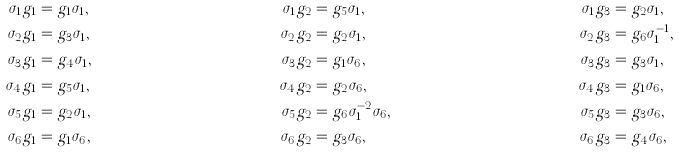<formula> <loc_0><loc_0><loc_500><loc_500>\sigma _ { 1 } g _ { 1 } & = g _ { 1 } \sigma _ { 1 } , & \sigma _ { 1 } g _ { 2 } & = g _ { 5 } \sigma _ { 1 } , & \sigma _ { 1 } g _ { 3 } & = g _ { 2 } \sigma _ { 1 } , \\ \sigma _ { 2 } g _ { 1 } & = g _ { 3 } \sigma _ { 1 } , & \sigma _ { 2 } g _ { 2 } & = g _ { 2 } \sigma _ { 1 } , & \sigma _ { 2 } g _ { 3 } & = g _ { 6 } \sigma _ { 1 } ^ { - 1 } , \\ \sigma _ { 3 } g _ { 1 } & = g _ { 4 } \sigma _ { 1 } , & \sigma _ { 3 } g _ { 2 } & = g _ { 1 } \sigma _ { 6 } , & \sigma _ { 3 } g _ { 3 } & = g _ { 3 } \sigma _ { 1 } , \\ \sigma _ { 4 } g _ { 1 } & = g _ { 5 } \sigma _ { 1 } , & \sigma _ { 4 } g _ { 2 } & = g _ { 2 } \sigma _ { 6 } , & \sigma _ { 4 } g _ { 3 } & = g _ { 1 } \sigma _ { 6 } , \\ \sigma _ { 5 } g _ { 1 } & = g _ { 2 } \sigma _ { 1 } , & \sigma _ { 5 } g _ { 2 } & = g _ { 6 } \sigma _ { 1 } ^ { - 2 } \sigma _ { 6 } , & \sigma _ { 5 } g _ { 3 } & = g _ { 3 } \sigma _ { 6 } , \\ \sigma _ { 6 } g _ { 1 } & = g _ { 1 } \sigma _ { 6 } , & \sigma _ { 6 } g _ { 2 } & = g _ { 3 } \sigma _ { 6 } , & \sigma _ { 6 } g _ { 3 } & = g _ { 4 } \sigma _ { 6 } ,</formula> 